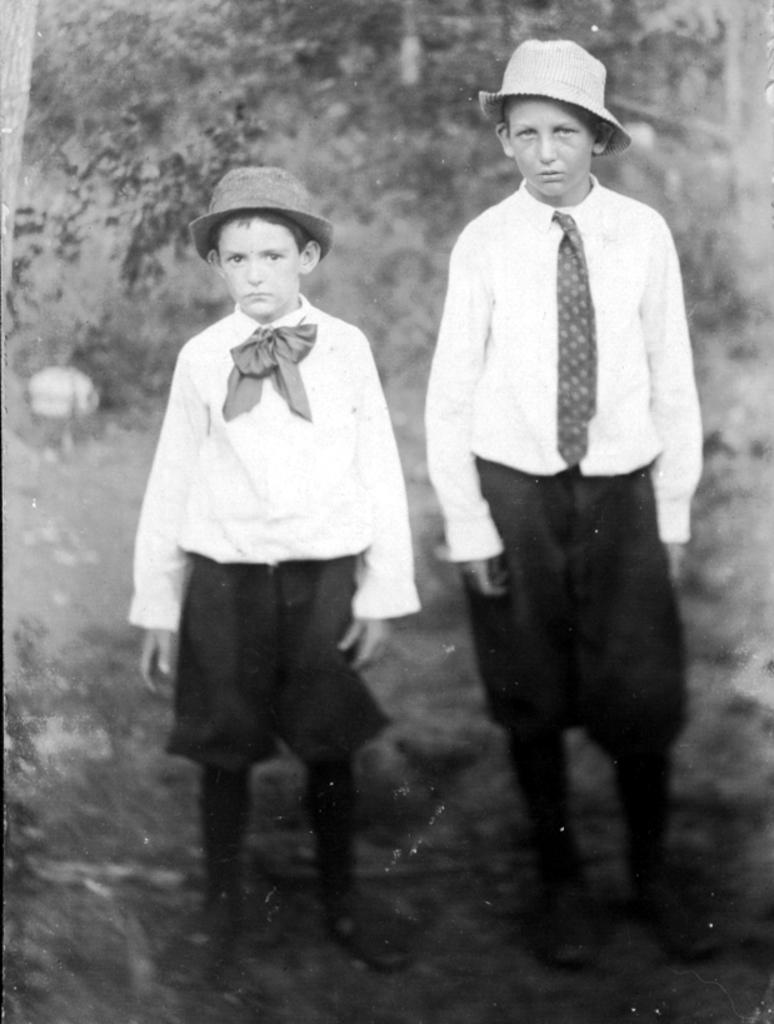What can be seen in the image? There are kids in the image. What are the kids wearing on their heads? The kids are wearing hats. Can you describe the background of the image? The background of the image is blurred. What type of caption is written under the kids in the image? There is no caption present under the kids in the image. What type of business is being conducted by the kids in the image? The image does not depict any business activities; it simply shows kids wearing hats. 